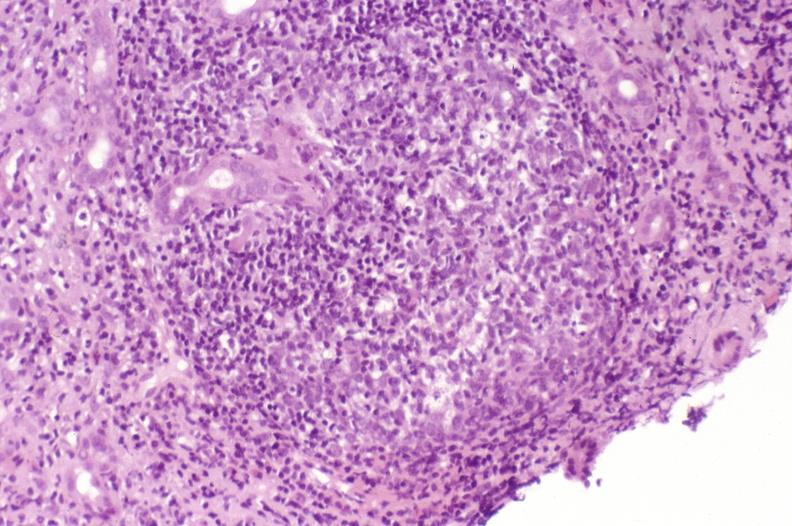s blood present?
Answer the question using a single word or phrase. No 